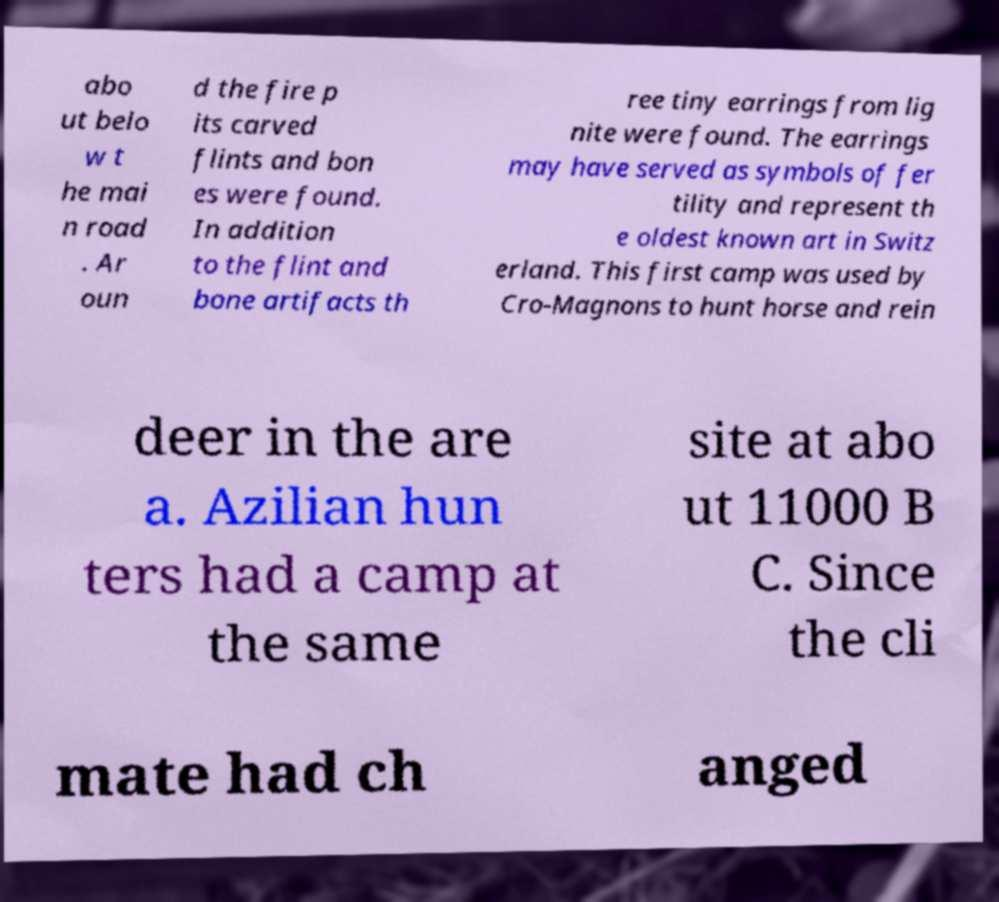I need the written content from this picture converted into text. Can you do that? abo ut belo w t he mai n road . Ar oun d the fire p its carved flints and bon es were found. In addition to the flint and bone artifacts th ree tiny earrings from lig nite were found. The earrings may have served as symbols of fer tility and represent th e oldest known art in Switz erland. This first camp was used by Cro-Magnons to hunt horse and rein deer in the are a. Azilian hun ters had a camp at the same site at abo ut 11000 B C. Since the cli mate had ch anged 